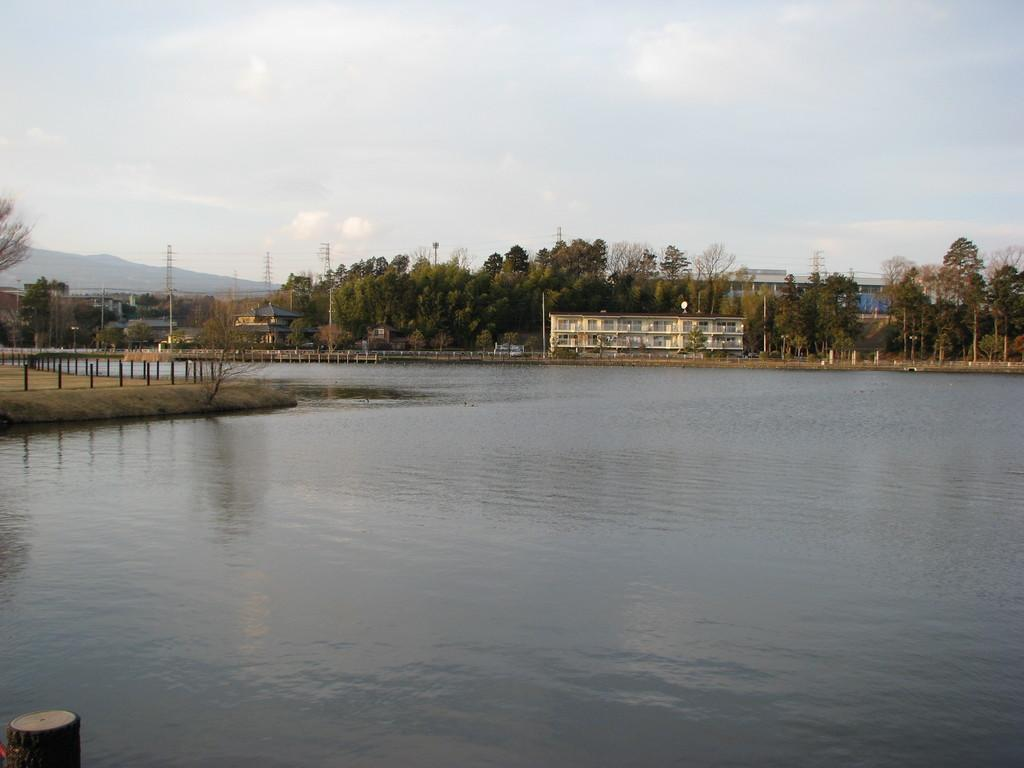What body of water is present in the image? There is a lake in the image. What structures can be seen behind the lake? There are buildings behind the lake. What type of infrastructure is present in the image? Electric poles with cables are present in the image. What type of vegetation is visible in the image? Trees are visible in the image. What geographical feature is present in the background of the image? There is a hill in the background. What part of the natural environment is visible in the image? The sky is visible in the image. How many cakes are being served on the sidewalk in the image? There are no cakes or sidewalks present in the image. What is the tongue's role in the image? There is no tongue present in the image. 